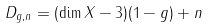Convert formula to latex. <formula><loc_0><loc_0><loc_500><loc_500>D _ { g , n } = ( \dim X - 3 ) ( 1 - g ) + n</formula> 